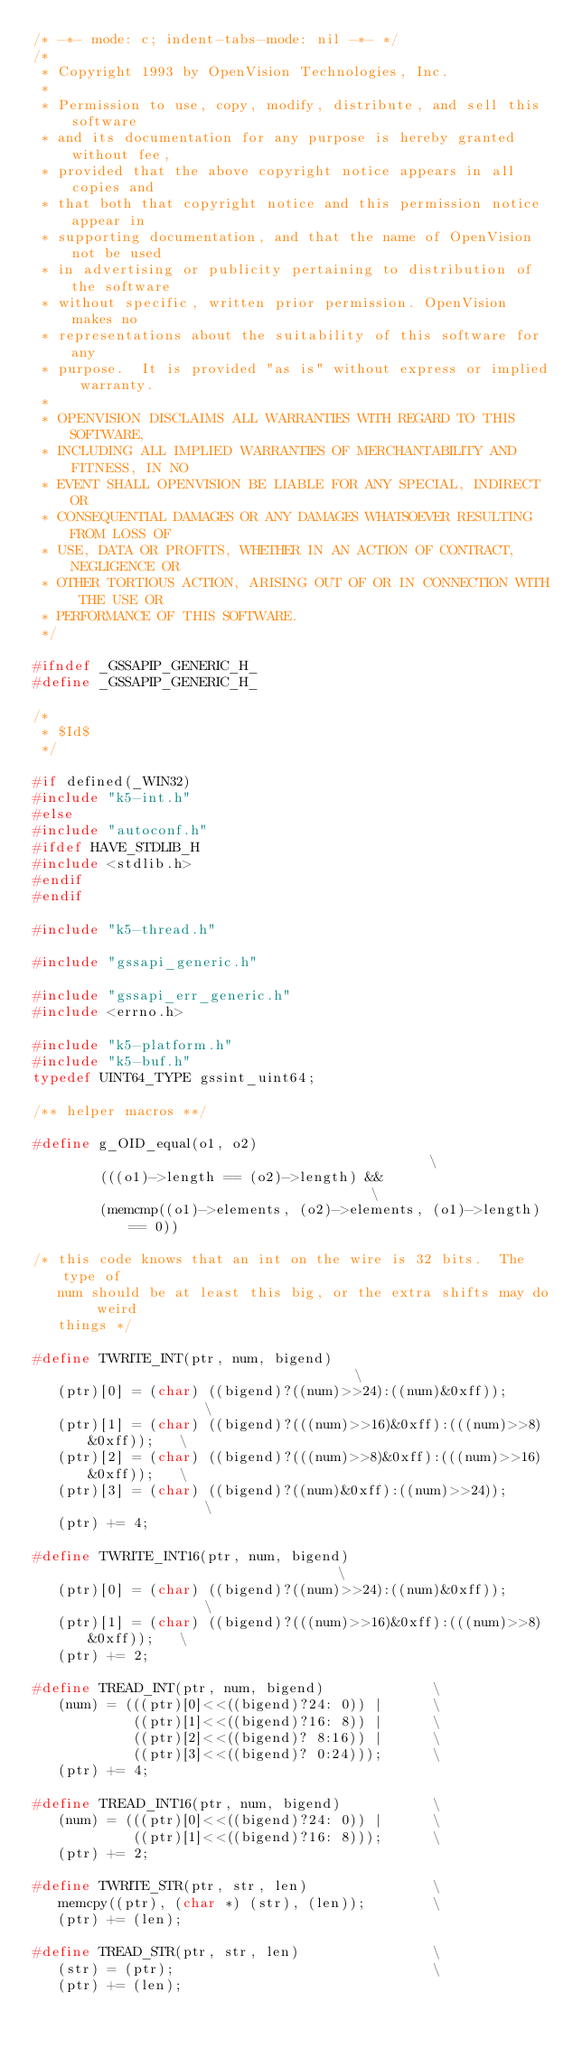<code> <loc_0><loc_0><loc_500><loc_500><_C_>/* -*- mode: c; indent-tabs-mode: nil -*- */
/*
 * Copyright 1993 by OpenVision Technologies, Inc.
 *
 * Permission to use, copy, modify, distribute, and sell this software
 * and its documentation for any purpose is hereby granted without fee,
 * provided that the above copyright notice appears in all copies and
 * that both that copyright notice and this permission notice appear in
 * supporting documentation, and that the name of OpenVision not be used
 * in advertising or publicity pertaining to distribution of the software
 * without specific, written prior permission. OpenVision makes no
 * representations about the suitability of this software for any
 * purpose.  It is provided "as is" without express or implied warranty.
 *
 * OPENVISION DISCLAIMS ALL WARRANTIES WITH REGARD TO THIS SOFTWARE,
 * INCLUDING ALL IMPLIED WARRANTIES OF MERCHANTABILITY AND FITNESS, IN NO
 * EVENT SHALL OPENVISION BE LIABLE FOR ANY SPECIAL, INDIRECT OR
 * CONSEQUENTIAL DAMAGES OR ANY DAMAGES WHATSOEVER RESULTING FROM LOSS OF
 * USE, DATA OR PROFITS, WHETHER IN AN ACTION OF CONTRACT, NEGLIGENCE OR
 * OTHER TORTIOUS ACTION, ARISING OUT OF OR IN CONNECTION WITH THE USE OR
 * PERFORMANCE OF THIS SOFTWARE.
 */

#ifndef _GSSAPIP_GENERIC_H_
#define _GSSAPIP_GENERIC_H_

/*
 * $Id$
 */

#if defined(_WIN32)
#include "k5-int.h"
#else
#include "autoconf.h"
#ifdef HAVE_STDLIB_H
#include <stdlib.h>
#endif
#endif

#include "k5-thread.h"

#include "gssapi_generic.h"

#include "gssapi_err_generic.h"
#include <errno.h>

#include "k5-platform.h"
#include "k5-buf.h"
typedef UINT64_TYPE gssint_uint64;

/** helper macros **/

#define g_OID_equal(o1, o2)                                             \
        (((o1)->length == (o2)->length) &&                              \
        (memcmp((o1)->elements, (o2)->elements, (o1)->length) == 0))

/* this code knows that an int on the wire is 32 bits.  The type of
   num should be at least this big, or the extra shifts may do weird
   things */

#define TWRITE_INT(ptr, num, bigend)                                    \
   (ptr)[0] = (char) ((bigend)?((num)>>24):((num)&0xff));               \
   (ptr)[1] = (char) ((bigend)?(((num)>>16)&0xff):(((num)>>8)&0xff));   \
   (ptr)[2] = (char) ((bigend)?(((num)>>8)&0xff):(((num)>>16)&0xff));   \
   (ptr)[3] = (char) ((bigend)?((num)&0xff):((num)>>24));               \
   (ptr) += 4;

#define TWRITE_INT16(ptr, num, bigend)                                  \
   (ptr)[0] = (char) ((bigend)?((num)>>24):((num)&0xff));               \
   (ptr)[1] = (char) ((bigend)?(((num)>>16)&0xff):(((num)>>8)&0xff));   \
   (ptr) += 2;

#define TREAD_INT(ptr, num, bigend)             \
   (num) = (((ptr)[0]<<((bigend)?24: 0)) |      \
            ((ptr)[1]<<((bigend)?16: 8)) |      \
            ((ptr)[2]<<((bigend)? 8:16)) |      \
            ((ptr)[3]<<((bigend)? 0:24)));      \
   (ptr) += 4;

#define TREAD_INT16(ptr, num, bigend)           \
   (num) = (((ptr)[0]<<((bigend)?24: 0)) |      \
            ((ptr)[1]<<((bigend)?16: 8)));      \
   (ptr) += 2;

#define TWRITE_STR(ptr, str, len)               \
   memcpy((ptr), (char *) (str), (len));        \
   (ptr) += (len);

#define TREAD_STR(ptr, str, len)                \
   (str) = (ptr);                               \
   (ptr) += (len);
</code> 